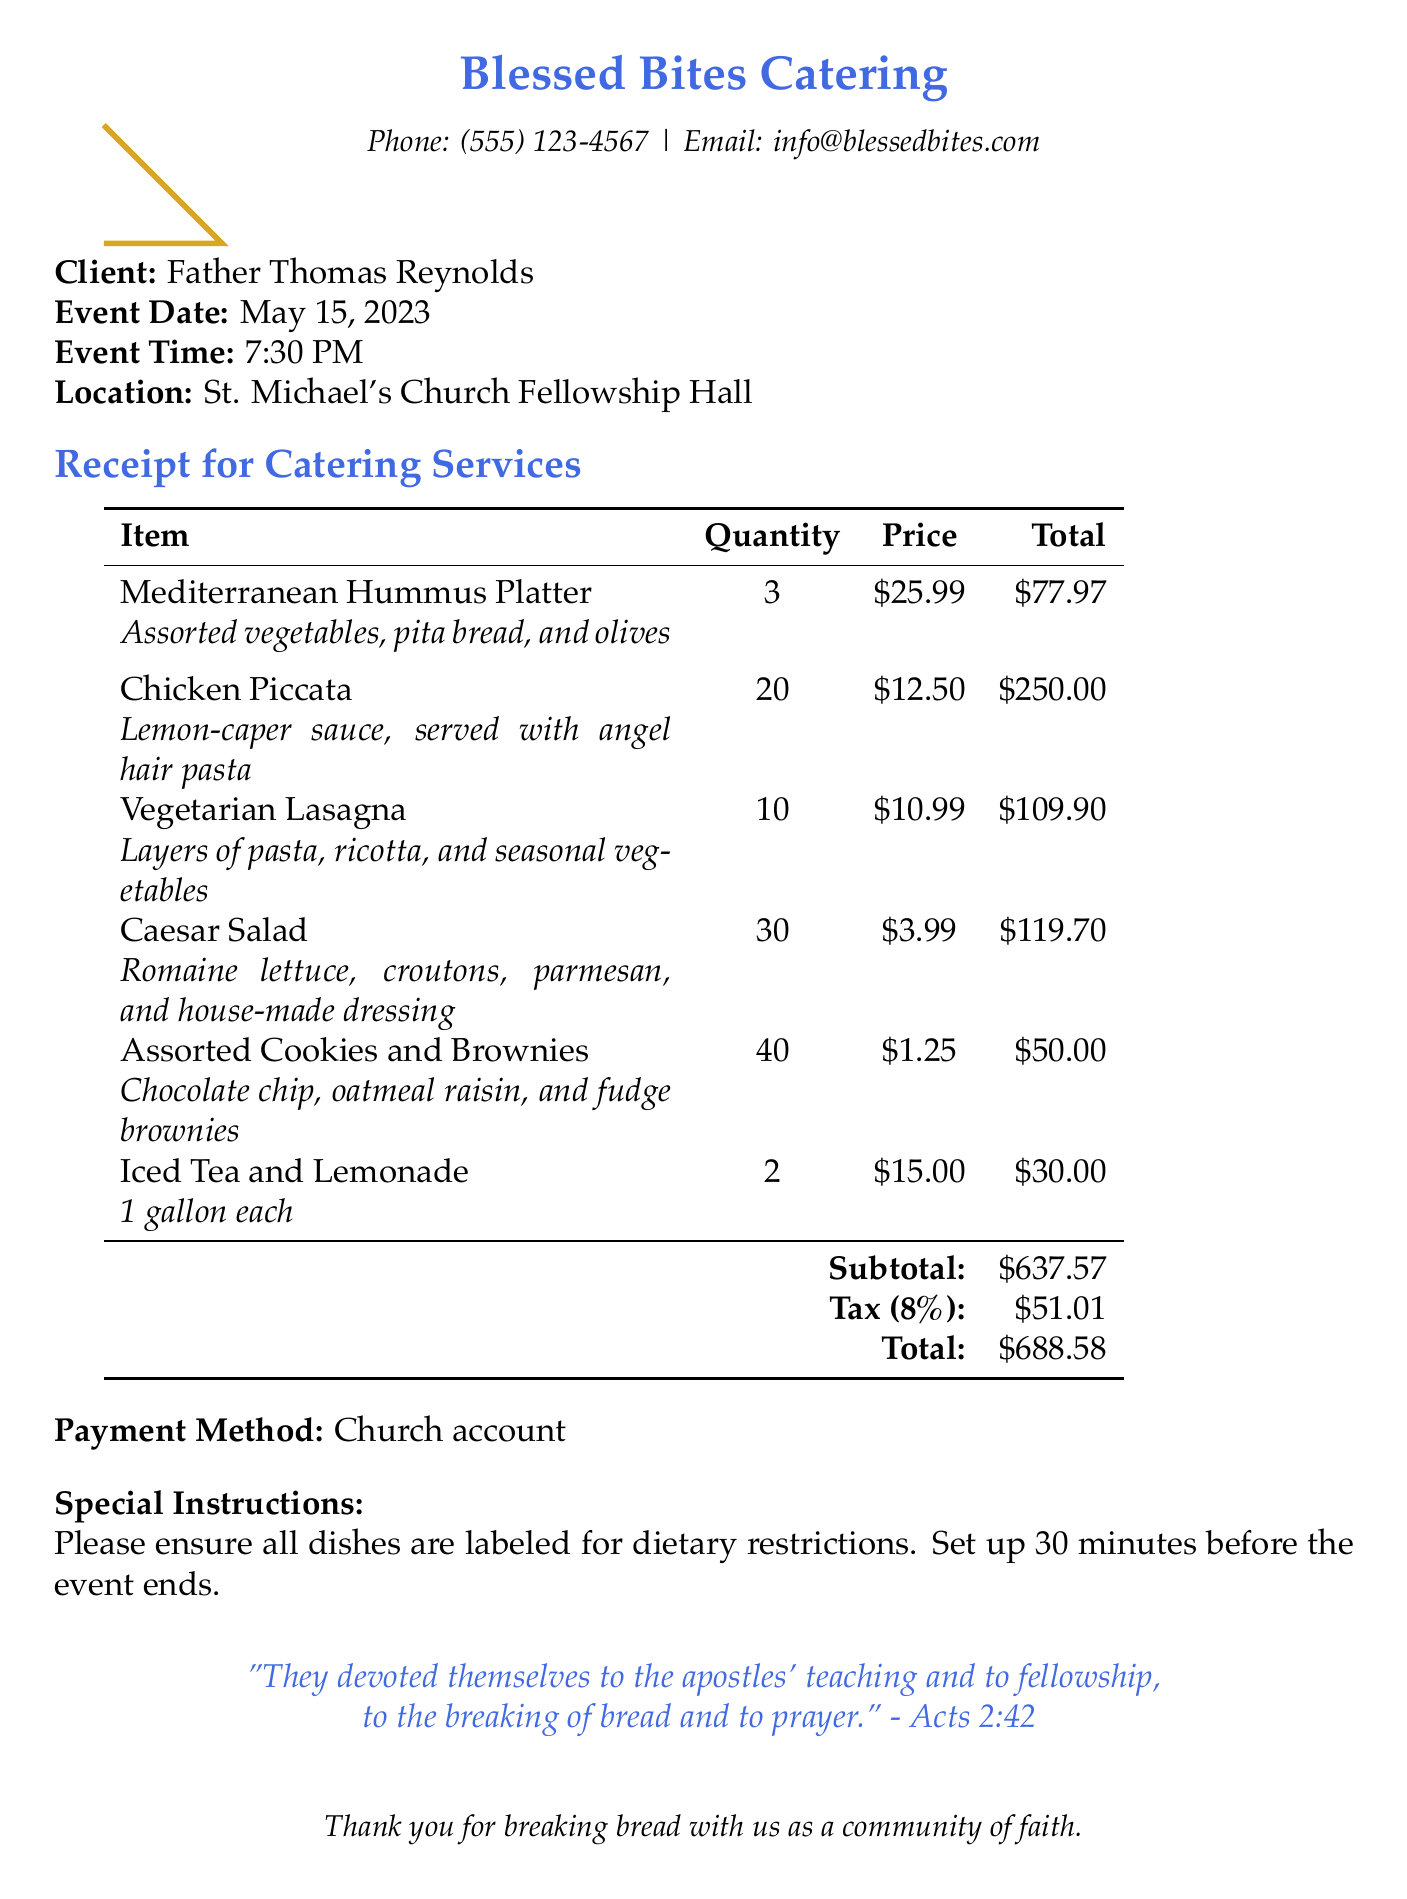What is the business name? The business name is listed at the top of the document, stating who provided the catering services.
Answer: Blessed Bites Catering What is the total amount due? The total amount is calculated as the subtotal plus tax, found near the bottom of the document.
Answer: $688.58 How many quantities of Chicken Piccata were ordered? The quantity of Chicken Piccata is specifically noted in the itemized list of menu items.
Answer: 20 What is the date of the event? The event date is clearly indicated in the event details section of the receipt.
Answer: May 15, 2023 What special instructions are provided? Special instructions are detailed towards the end of the document, indicating specific requests for the catering service.
Answer: Please ensure all dishes are labeled for dietary restrictions. Set up 30 minutes before the event ends How much was charged for Caesar Salad? The amount charged for Caesar Salad is presented in the itemized breakdown of the menu items.
Answer: $119.70 What payment method was used? The payment method is noted in the document, indicating how the service was paid for.
Answer: Church account What is the theological theme mentioned? The theological theme is a specific element highlighted in the document related to the event's focus.
Answer: Breaking bread together as a community of faith How many types of desserts were included in the menu? The count of dessert types is derived from the item description provided in the menu section.
Answer: 3 (Chocolate chip, oatmeal raisin, and fudge brownies) 